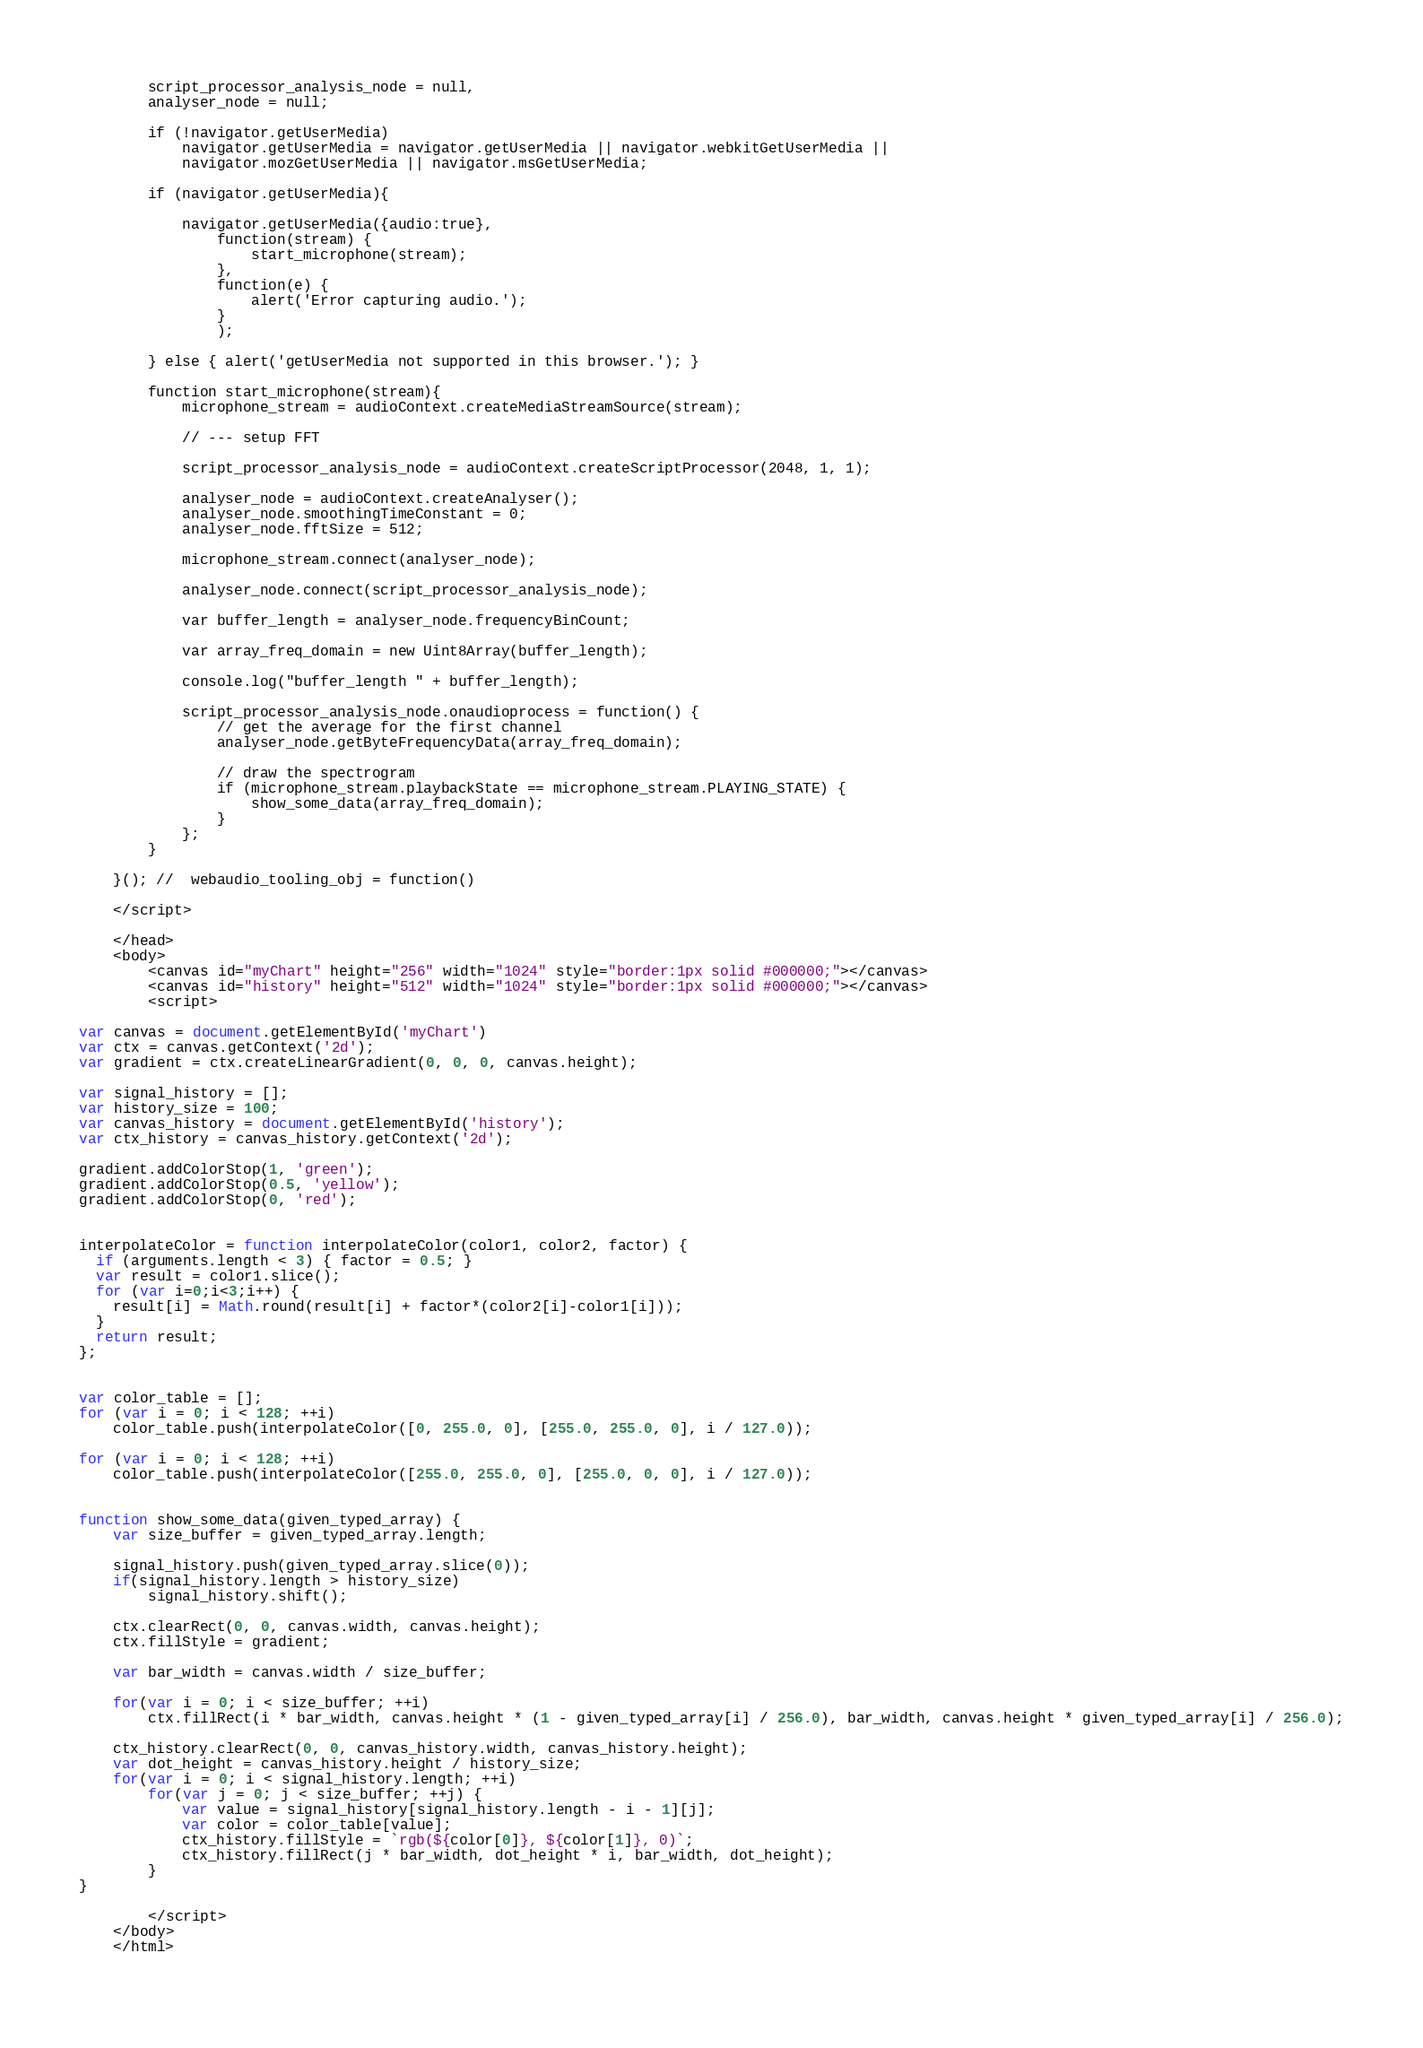<code> <loc_0><loc_0><loc_500><loc_500><_HTML_>        script_processor_analysis_node = null,
        analyser_node = null;
    
        if (!navigator.getUserMedia)
            navigator.getUserMedia = navigator.getUserMedia || navigator.webkitGetUserMedia ||
            navigator.mozGetUserMedia || navigator.msGetUserMedia;
    
        if (navigator.getUserMedia){
    
            navigator.getUserMedia({audio:true}, 
                function(stream) {
                    start_microphone(stream);
                },
                function(e) {
                    alert('Error capturing audio.');
                }
                );
    
        } else { alert('getUserMedia not supported in this browser.'); }   
    
        function start_microphone(stream){
            microphone_stream = audioContext.createMediaStreamSource(stream);
    
            // --- setup FFT
    
            script_processor_analysis_node = audioContext.createScriptProcessor(2048, 1, 1);
    
            analyser_node = audioContext.createAnalyser();
            analyser_node.smoothingTimeConstant = 0;
            analyser_node.fftSize = 512;
    
            microphone_stream.connect(analyser_node);
    
            analyser_node.connect(script_processor_analysis_node);
    
            var buffer_length = analyser_node.frequencyBinCount;
    
            var array_freq_domain = new Uint8Array(buffer_length);
    
            console.log("buffer_length " + buffer_length);
    
            script_processor_analysis_node.onaudioprocess = function() {
                // get the average for the first channel
                analyser_node.getByteFrequencyData(array_freq_domain);
    
                // draw the spectrogram
                if (microphone_stream.playbackState == microphone_stream.PLAYING_STATE) {    
                    show_some_data(array_freq_domain);
                }
            };
        }
    
    }(); //  webaudio_tooling_obj = function()

    </script>
    
    </head>
    <body>
        <canvas id="myChart" height="256" width="1024" style="border:1px solid #000000;"></canvas>
        <canvas id="history" height="512" width="1024" style="border:1px solid #000000;"></canvas>
        <script>

var canvas = document.getElementById('myChart')
var ctx = canvas.getContext('2d');
var gradient = ctx.createLinearGradient(0, 0, 0, canvas.height);

var signal_history = [];
var history_size = 100;
var canvas_history = document.getElementById('history');
var ctx_history = canvas_history.getContext('2d');

gradient.addColorStop(1, 'green');
gradient.addColorStop(0.5, 'yellow');
gradient.addColorStop(0, 'red');


interpolateColor = function interpolateColor(color1, color2, factor) {
  if (arguments.length < 3) { factor = 0.5; }
  var result = color1.slice();
  for (var i=0;i<3;i++) {
    result[i] = Math.round(result[i] + factor*(color2[i]-color1[i]));
  }
  return result;
};


var color_table = [];
for (var i = 0; i < 128; ++i)
    color_table.push(interpolateColor([0, 255.0, 0], [255.0, 255.0, 0], i / 127.0));

for (var i = 0; i < 128; ++i)
    color_table.push(interpolateColor([255.0, 255.0, 0], [255.0, 0, 0], i / 127.0));


function show_some_data(given_typed_array) {    
    var size_buffer = given_typed_array.length;

    signal_history.push(given_typed_array.slice(0));
    if(signal_history.length > history_size)
        signal_history.shift();

    ctx.clearRect(0, 0, canvas.width, canvas.height);
    ctx.fillStyle = gradient;

    var bar_width = canvas.width / size_buffer;

    for(var i = 0; i < size_buffer; ++i)
        ctx.fillRect(i * bar_width, canvas.height * (1 - given_typed_array[i] / 256.0), bar_width, canvas.height * given_typed_array[i] / 256.0);

    ctx_history.clearRect(0, 0, canvas_history.width, canvas_history.height);
    var dot_height = canvas_history.height / history_size;
    for(var i = 0; i < signal_history.length; ++i)
        for(var j = 0; j < size_buffer; ++j) {
            var value = signal_history[signal_history.length - i - 1][j];
            var color = color_table[value];
            ctx_history.fillStyle = `rgb(${color[0]}, ${color[1]}, 0)`;
            ctx_history.fillRect(j * bar_width, dot_height * i, bar_width, dot_height);
        }
}

        </script>
    </body>
    </html>
    </code> 